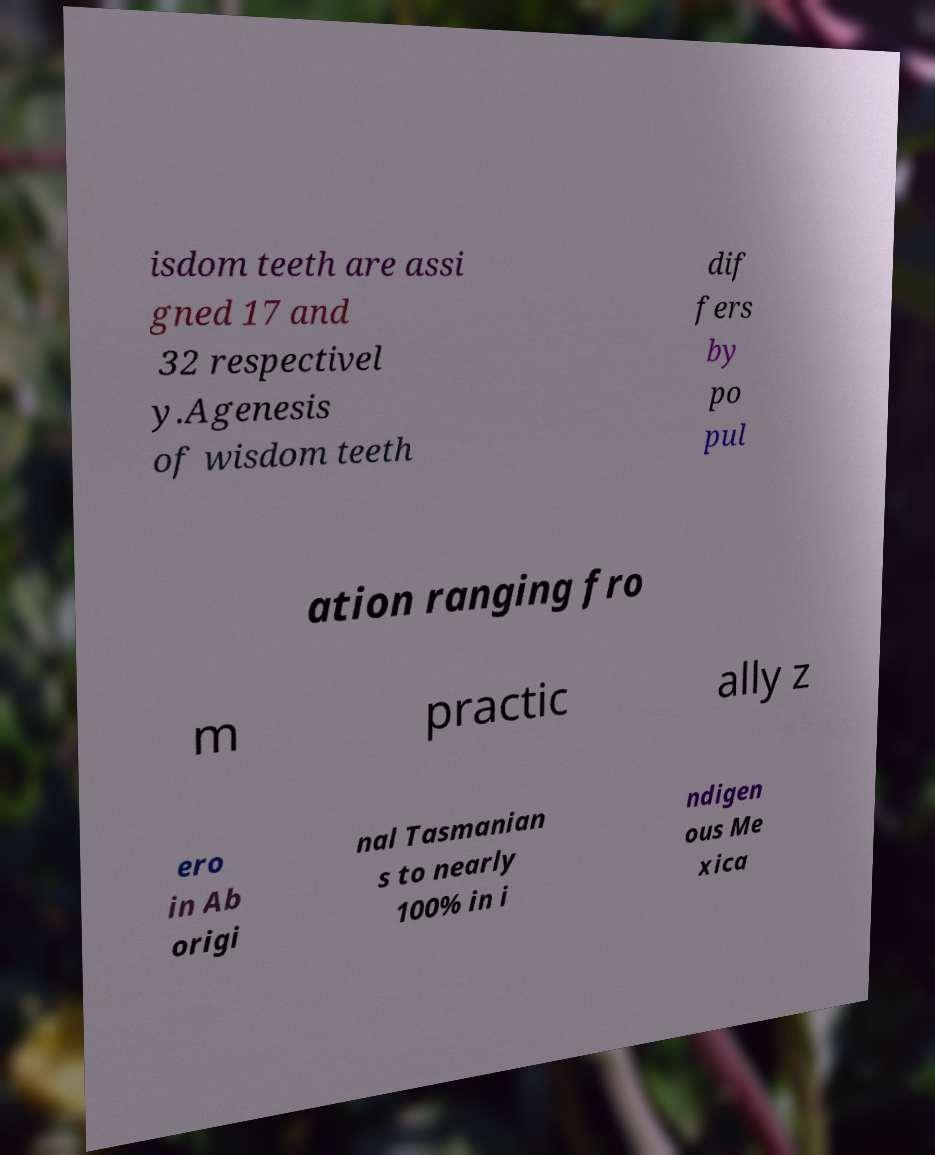Could you extract and type out the text from this image? isdom teeth are assi gned 17 and 32 respectivel y.Agenesis of wisdom teeth dif fers by po pul ation ranging fro m practic ally z ero in Ab origi nal Tasmanian s to nearly 100% in i ndigen ous Me xica 